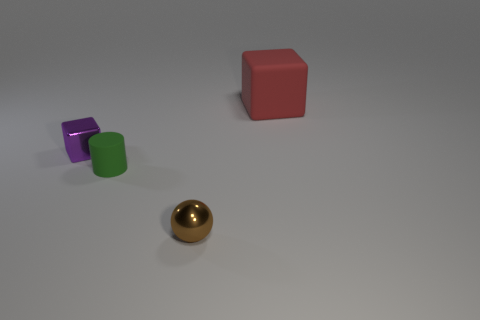Add 2 small cylinders. How many objects exist? 6 Subtract 1 cylinders. How many cylinders are left? 0 Subtract all balls. How many objects are left? 3 Subtract all gray rubber blocks. Subtract all green matte things. How many objects are left? 3 Add 3 small objects. How many small objects are left? 6 Add 3 rubber blocks. How many rubber blocks exist? 4 Subtract 0 blue blocks. How many objects are left? 4 Subtract all green cubes. Subtract all red cylinders. How many cubes are left? 2 